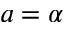<formula> <loc_0><loc_0><loc_500><loc_500>a = \alpha</formula> 